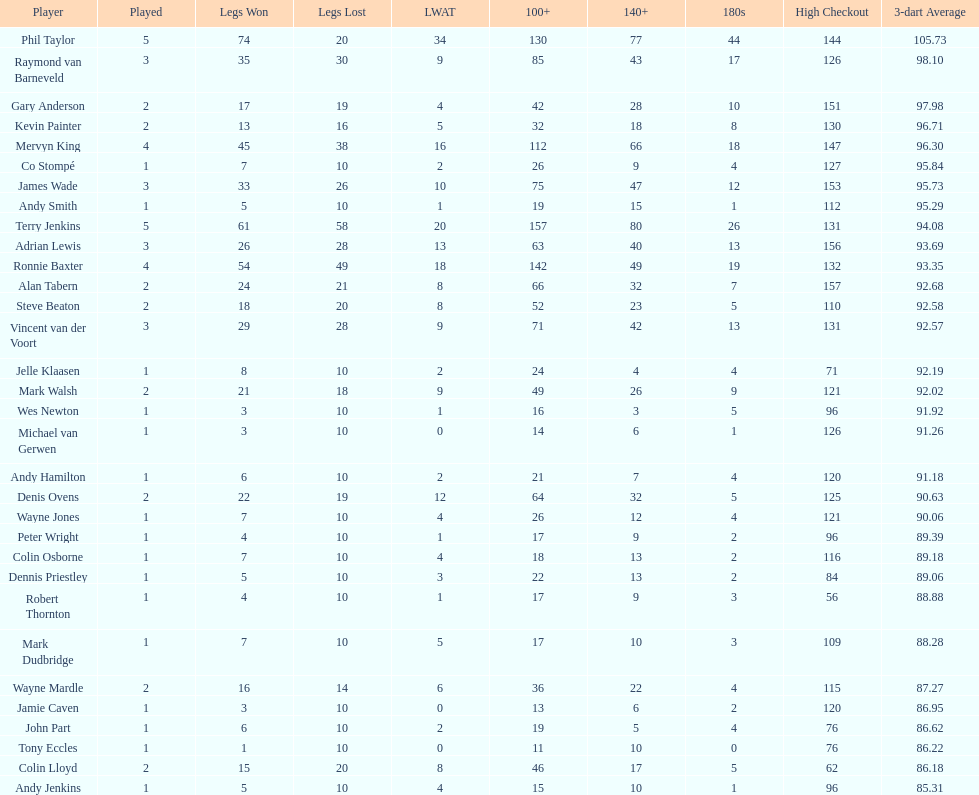Help me parse the entirety of this table. {'header': ['Player', 'Played', 'Legs Won', 'Legs Lost', 'LWAT', '100+', '140+', '180s', 'High Checkout', '3-dart Average'], 'rows': [['Phil Taylor', '5', '74', '20', '34', '130', '77', '44', '144', '105.73'], ['Raymond van Barneveld', '3', '35', '30', '9', '85', '43', '17', '126', '98.10'], ['Gary Anderson', '2', '17', '19', '4', '42', '28', '10', '151', '97.98'], ['Kevin Painter', '2', '13', '16', '5', '32', '18', '8', '130', '96.71'], ['Mervyn King', '4', '45', '38', '16', '112', '66', '18', '147', '96.30'], ['Co Stompé', '1', '7', '10', '2', '26', '9', '4', '127', '95.84'], ['James Wade', '3', '33', '26', '10', '75', '47', '12', '153', '95.73'], ['Andy Smith', '1', '5', '10', '1', '19', '15', '1', '112', '95.29'], ['Terry Jenkins', '5', '61', '58', '20', '157', '80', '26', '131', '94.08'], ['Adrian Lewis', '3', '26', '28', '13', '63', '40', '13', '156', '93.69'], ['Ronnie Baxter', '4', '54', '49', '18', '142', '49', '19', '132', '93.35'], ['Alan Tabern', '2', '24', '21', '8', '66', '32', '7', '157', '92.68'], ['Steve Beaton', '2', '18', '20', '8', '52', '23', '5', '110', '92.58'], ['Vincent van der Voort', '3', '29', '28', '9', '71', '42', '13', '131', '92.57'], ['Jelle Klaasen', '1', '8', '10', '2', '24', '4', '4', '71', '92.19'], ['Mark Walsh', '2', '21', '18', '9', '49', '26', '9', '121', '92.02'], ['Wes Newton', '1', '3', '10', '1', '16', '3', '5', '96', '91.92'], ['Michael van Gerwen', '1', '3', '10', '0', '14', '6', '1', '126', '91.26'], ['Andy Hamilton', '1', '6', '10', '2', '21', '7', '4', '120', '91.18'], ['Denis Ovens', '2', '22', '19', '12', '64', '32', '5', '125', '90.63'], ['Wayne Jones', '1', '7', '10', '4', '26', '12', '4', '121', '90.06'], ['Peter Wright', '1', '4', '10', '1', '17', '9', '2', '96', '89.39'], ['Colin Osborne', '1', '7', '10', '4', '18', '13', '2', '116', '89.18'], ['Dennis Priestley', '1', '5', '10', '3', '22', '13', '2', '84', '89.06'], ['Robert Thornton', '1', '4', '10', '1', '17', '9', '3', '56', '88.88'], ['Mark Dudbridge', '1', '7', '10', '5', '17', '10', '3', '109', '88.28'], ['Wayne Mardle', '2', '16', '14', '6', '36', '22', '4', '115', '87.27'], ['Jamie Caven', '1', '3', '10', '0', '13', '6', '2', '120', '86.95'], ['John Part', '1', '6', '10', '2', '19', '5', '4', '76', '86.62'], ['Tony Eccles', '1', '1', '10', '0', '11', '10', '0', '76', '86.22'], ['Colin Lloyd', '2', '15', '20', '8', '46', '17', '5', '62', '86.18'], ['Andy Jenkins', '1', '5', '10', '4', '15', '10', '1', '96', '85.31']]} Who claimed the most legs in the 2009 world matchplay? Phil Taylor. 